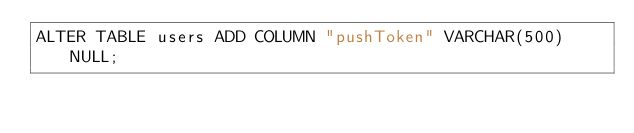Convert code to text. <code><loc_0><loc_0><loc_500><loc_500><_SQL_>ALTER TABLE users ADD COLUMN "pushToken" VARCHAR(500) NULL;
</code> 